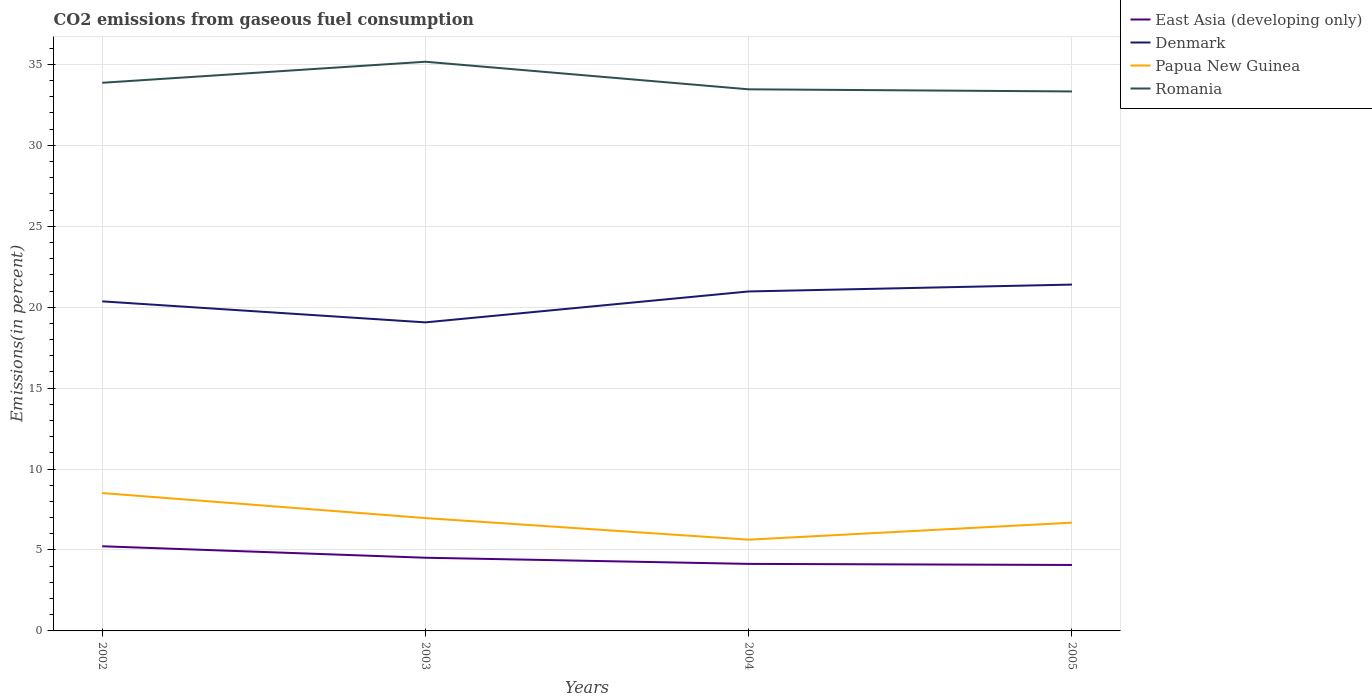Is the number of lines equal to the number of legend labels?
Provide a short and direct response. Yes. Across all years, what is the maximum total CO2 emitted in Denmark?
Offer a terse response. 19.06. In which year was the total CO2 emitted in East Asia (developing only) maximum?
Offer a very short reply. 2005. What is the total total CO2 emitted in Denmark in the graph?
Keep it short and to the point. -1.04. What is the difference between the highest and the second highest total CO2 emitted in Papua New Guinea?
Your answer should be very brief. 2.88. What is the difference between the highest and the lowest total CO2 emitted in East Asia (developing only)?
Provide a succinct answer. 2. How many lines are there?
Your response must be concise. 4. How many years are there in the graph?
Ensure brevity in your answer.  4. What is the difference between two consecutive major ticks on the Y-axis?
Your answer should be compact. 5. Where does the legend appear in the graph?
Offer a terse response. Top right. How are the legend labels stacked?
Your response must be concise. Vertical. What is the title of the graph?
Make the answer very short. CO2 emissions from gaseous fuel consumption. What is the label or title of the Y-axis?
Your answer should be very brief. Emissions(in percent). What is the Emissions(in percent) of East Asia (developing only) in 2002?
Keep it short and to the point. 5.23. What is the Emissions(in percent) in Denmark in 2002?
Provide a short and direct response. 20.36. What is the Emissions(in percent) of Papua New Guinea in 2002?
Ensure brevity in your answer.  8.52. What is the Emissions(in percent) in Romania in 2002?
Your answer should be very brief. 33.86. What is the Emissions(in percent) in East Asia (developing only) in 2003?
Offer a terse response. 4.52. What is the Emissions(in percent) of Denmark in 2003?
Your answer should be compact. 19.06. What is the Emissions(in percent) in Papua New Guinea in 2003?
Provide a succinct answer. 6.97. What is the Emissions(in percent) of Romania in 2003?
Offer a very short reply. 35.16. What is the Emissions(in percent) of East Asia (developing only) in 2004?
Provide a short and direct response. 4.14. What is the Emissions(in percent) of Denmark in 2004?
Ensure brevity in your answer.  20.97. What is the Emissions(in percent) of Papua New Guinea in 2004?
Your response must be concise. 5.64. What is the Emissions(in percent) of Romania in 2004?
Your answer should be compact. 33.46. What is the Emissions(in percent) in East Asia (developing only) in 2005?
Provide a succinct answer. 4.07. What is the Emissions(in percent) in Denmark in 2005?
Ensure brevity in your answer.  21.4. What is the Emissions(in percent) in Papua New Guinea in 2005?
Provide a short and direct response. 6.69. What is the Emissions(in percent) of Romania in 2005?
Give a very brief answer. 33.33. Across all years, what is the maximum Emissions(in percent) of East Asia (developing only)?
Provide a succinct answer. 5.23. Across all years, what is the maximum Emissions(in percent) in Denmark?
Provide a short and direct response. 21.4. Across all years, what is the maximum Emissions(in percent) of Papua New Guinea?
Your answer should be compact. 8.52. Across all years, what is the maximum Emissions(in percent) of Romania?
Provide a short and direct response. 35.16. Across all years, what is the minimum Emissions(in percent) in East Asia (developing only)?
Keep it short and to the point. 4.07. Across all years, what is the minimum Emissions(in percent) of Denmark?
Offer a very short reply. 19.06. Across all years, what is the minimum Emissions(in percent) of Papua New Guinea?
Your response must be concise. 5.64. Across all years, what is the minimum Emissions(in percent) in Romania?
Give a very brief answer. 33.33. What is the total Emissions(in percent) of East Asia (developing only) in the graph?
Make the answer very short. 17.97. What is the total Emissions(in percent) in Denmark in the graph?
Offer a terse response. 81.79. What is the total Emissions(in percent) in Papua New Guinea in the graph?
Provide a short and direct response. 27.81. What is the total Emissions(in percent) of Romania in the graph?
Keep it short and to the point. 135.82. What is the difference between the Emissions(in percent) in East Asia (developing only) in 2002 and that in 2003?
Provide a succinct answer. 0.71. What is the difference between the Emissions(in percent) of Denmark in 2002 and that in 2003?
Give a very brief answer. 1.3. What is the difference between the Emissions(in percent) in Papua New Guinea in 2002 and that in 2003?
Your answer should be compact. 1.55. What is the difference between the Emissions(in percent) of Romania in 2002 and that in 2003?
Give a very brief answer. -1.3. What is the difference between the Emissions(in percent) in East Asia (developing only) in 2002 and that in 2004?
Keep it short and to the point. 1.09. What is the difference between the Emissions(in percent) in Denmark in 2002 and that in 2004?
Ensure brevity in your answer.  -0.61. What is the difference between the Emissions(in percent) of Papua New Guinea in 2002 and that in 2004?
Offer a very short reply. 2.88. What is the difference between the Emissions(in percent) in Romania in 2002 and that in 2004?
Make the answer very short. 0.4. What is the difference between the Emissions(in percent) in East Asia (developing only) in 2002 and that in 2005?
Offer a very short reply. 1.16. What is the difference between the Emissions(in percent) in Denmark in 2002 and that in 2005?
Offer a very short reply. -1.04. What is the difference between the Emissions(in percent) in Papua New Guinea in 2002 and that in 2005?
Your response must be concise. 1.83. What is the difference between the Emissions(in percent) of Romania in 2002 and that in 2005?
Offer a terse response. 0.53. What is the difference between the Emissions(in percent) in East Asia (developing only) in 2003 and that in 2004?
Provide a succinct answer. 0.38. What is the difference between the Emissions(in percent) of Denmark in 2003 and that in 2004?
Provide a short and direct response. -1.91. What is the difference between the Emissions(in percent) in Papua New Guinea in 2003 and that in 2004?
Your response must be concise. 1.33. What is the difference between the Emissions(in percent) in Romania in 2003 and that in 2004?
Give a very brief answer. 1.7. What is the difference between the Emissions(in percent) of East Asia (developing only) in 2003 and that in 2005?
Your response must be concise. 0.45. What is the difference between the Emissions(in percent) of Denmark in 2003 and that in 2005?
Your response must be concise. -2.33. What is the difference between the Emissions(in percent) of Papua New Guinea in 2003 and that in 2005?
Make the answer very short. 0.28. What is the difference between the Emissions(in percent) in Romania in 2003 and that in 2005?
Provide a short and direct response. 1.83. What is the difference between the Emissions(in percent) of East Asia (developing only) in 2004 and that in 2005?
Offer a very short reply. 0.07. What is the difference between the Emissions(in percent) of Denmark in 2004 and that in 2005?
Offer a very short reply. -0.42. What is the difference between the Emissions(in percent) in Papua New Guinea in 2004 and that in 2005?
Your answer should be compact. -1.05. What is the difference between the Emissions(in percent) in Romania in 2004 and that in 2005?
Make the answer very short. 0.13. What is the difference between the Emissions(in percent) in East Asia (developing only) in 2002 and the Emissions(in percent) in Denmark in 2003?
Give a very brief answer. -13.83. What is the difference between the Emissions(in percent) in East Asia (developing only) in 2002 and the Emissions(in percent) in Papua New Guinea in 2003?
Provide a short and direct response. -1.74. What is the difference between the Emissions(in percent) in East Asia (developing only) in 2002 and the Emissions(in percent) in Romania in 2003?
Offer a very short reply. -29.93. What is the difference between the Emissions(in percent) of Denmark in 2002 and the Emissions(in percent) of Papua New Guinea in 2003?
Offer a terse response. 13.39. What is the difference between the Emissions(in percent) in Denmark in 2002 and the Emissions(in percent) in Romania in 2003?
Ensure brevity in your answer.  -14.8. What is the difference between the Emissions(in percent) in Papua New Guinea in 2002 and the Emissions(in percent) in Romania in 2003?
Make the answer very short. -26.65. What is the difference between the Emissions(in percent) of East Asia (developing only) in 2002 and the Emissions(in percent) of Denmark in 2004?
Keep it short and to the point. -15.74. What is the difference between the Emissions(in percent) in East Asia (developing only) in 2002 and the Emissions(in percent) in Papua New Guinea in 2004?
Offer a very short reply. -0.41. What is the difference between the Emissions(in percent) of East Asia (developing only) in 2002 and the Emissions(in percent) of Romania in 2004?
Make the answer very short. -28.23. What is the difference between the Emissions(in percent) in Denmark in 2002 and the Emissions(in percent) in Papua New Guinea in 2004?
Give a very brief answer. 14.72. What is the difference between the Emissions(in percent) in Denmark in 2002 and the Emissions(in percent) in Romania in 2004?
Your response must be concise. -13.1. What is the difference between the Emissions(in percent) in Papua New Guinea in 2002 and the Emissions(in percent) in Romania in 2004?
Make the answer very short. -24.94. What is the difference between the Emissions(in percent) in East Asia (developing only) in 2002 and the Emissions(in percent) in Denmark in 2005?
Your answer should be compact. -16.17. What is the difference between the Emissions(in percent) in East Asia (developing only) in 2002 and the Emissions(in percent) in Papua New Guinea in 2005?
Your answer should be compact. -1.46. What is the difference between the Emissions(in percent) in East Asia (developing only) in 2002 and the Emissions(in percent) in Romania in 2005?
Offer a terse response. -28.1. What is the difference between the Emissions(in percent) in Denmark in 2002 and the Emissions(in percent) in Papua New Guinea in 2005?
Keep it short and to the point. 13.67. What is the difference between the Emissions(in percent) in Denmark in 2002 and the Emissions(in percent) in Romania in 2005?
Provide a succinct answer. -12.97. What is the difference between the Emissions(in percent) in Papua New Guinea in 2002 and the Emissions(in percent) in Romania in 2005?
Ensure brevity in your answer.  -24.81. What is the difference between the Emissions(in percent) of East Asia (developing only) in 2003 and the Emissions(in percent) of Denmark in 2004?
Make the answer very short. -16.45. What is the difference between the Emissions(in percent) in East Asia (developing only) in 2003 and the Emissions(in percent) in Papua New Guinea in 2004?
Your response must be concise. -1.12. What is the difference between the Emissions(in percent) of East Asia (developing only) in 2003 and the Emissions(in percent) of Romania in 2004?
Your answer should be compact. -28.94. What is the difference between the Emissions(in percent) in Denmark in 2003 and the Emissions(in percent) in Papua New Guinea in 2004?
Make the answer very short. 13.43. What is the difference between the Emissions(in percent) of Denmark in 2003 and the Emissions(in percent) of Romania in 2004?
Your answer should be compact. -14.4. What is the difference between the Emissions(in percent) of Papua New Guinea in 2003 and the Emissions(in percent) of Romania in 2004?
Make the answer very short. -26.49. What is the difference between the Emissions(in percent) of East Asia (developing only) in 2003 and the Emissions(in percent) of Denmark in 2005?
Offer a very short reply. -16.88. What is the difference between the Emissions(in percent) in East Asia (developing only) in 2003 and the Emissions(in percent) in Papua New Guinea in 2005?
Your answer should be very brief. -2.17. What is the difference between the Emissions(in percent) in East Asia (developing only) in 2003 and the Emissions(in percent) in Romania in 2005?
Ensure brevity in your answer.  -28.81. What is the difference between the Emissions(in percent) of Denmark in 2003 and the Emissions(in percent) of Papua New Guinea in 2005?
Ensure brevity in your answer.  12.37. What is the difference between the Emissions(in percent) in Denmark in 2003 and the Emissions(in percent) in Romania in 2005?
Your answer should be very brief. -14.27. What is the difference between the Emissions(in percent) in Papua New Guinea in 2003 and the Emissions(in percent) in Romania in 2005?
Your answer should be very brief. -26.36. What is the difference between the Emissions(in percent) in East Asia (developing only) in 2004 and the Emissions(in percent) in Denmark in 2005?
Make the answer very short. -17.26. What is the difference between the Emissions(in percent) in East Asia (developing only) in 2004 and the Emissions(in percent) in Papua New Guinea in 2005?
Give a very brief answer. -2.55. What is the difference between the Emissions(in percent) in East Asia (developing only) in 2004 and the Emissions(in percent) in Romania in 2005?
Your answer should be very brief. -29.19. What is the difference between the Emissions(in percent) of Denmark in 2004 and the Emissions(in percent) of Papua New Guinea in 2005?
Offer a terse response. 14.28. What is the difference between the Emissions(in percent) of Denmark in 2004 and the Emissions(in percent) of Romania in 2005?
Give a very brief answer. -12.36. What is the difference between the Emissions(in percent) of Papua New Guinea in 2004 and the Emissions(in percent) of Romania in 2005?
Provide a succinct answer. -27.69. What is the average Emissions(in percent) of East Asia (developing only) per year?
Your answer should be very brief. 4.49. What is the average Emissions(in percent) in Denmark per year?
Provide a succinct answer. 20.45. What is the average Emissions(in percent) of Papua New Guinea per year?
Offer a very short reply. 6.95. What is the average Emissions(in percent) of Romania per year?
Offer a very short reply. 33.95. In the year 2002, what is the difference between the Emissions(in percent) of East Asia (developing only) and Emissions(in percent) of Denmark?
Your answer should be very brief. -15.13. In the year 2002, what is the difference between the Emissions(in percent) in East Asia (developing only) and Emissions(in percent) in Papua New Guinea?
Make the answer very short. -3.29. In the year 2002, what is the difference between the Emissions(in percent) of East Asia (developing only) and Emissions(in percent) of Romania?
Provide a short and direct response. -28.63. In the year 2002, what is the difference between the Emissions(in percent) in Denmark and Emissions(in percent) in Papua New Guinea?
Your response must be concise. 11.84. In the year 2002, what is the difference between the Emissions(in percent) in Denmark and Emissions(in percent) in Romania?
Provide a short and direct response. -13.5. In the year 2002, what is the difference between the Emissions(in percent) of Papua New Guinea and Emissions(in percent) of Romania?
Offer a terse response. -25.35. In the year 2003, what is the difference between the Emissions(in percent) of East Asia (developing only) and Emissions(in percent) of Denmark?
Offer a terse response. -14.54. In the year 2003, what is the difference between the Emissions(in percent) in East Asia (developing only) and Emissions(in percent) in Papua New Guinea?
Make the answer very short. -2.45. In the year 2003, what is the difference between the Emissions(in percent) of East Asia (developing only) and Emissions(in percent) of Romania?
Provide a succinct answer. -30.64. In the year 2003, what is the difference between the Emissions(in percent) in Denmark and Emissions(in percent) in Papua New Guinea?
Provide a short and direct response. 12.09. In the year 2003, what is the difference between the Emissions(in percent) of Denmark and Emissions(in percent) of Romania?
Offer a very short reply. -16.1. In the year 2003, what is the difference between the Emissions(in percent) in Papua New Guinea and Emissions(in percent) in Romania?
Give a very brief answer. -28.19. In the year 2004, what is the difference between the Emissions(in percent) of East Asia (developing only) and Emissions(in percent) of Denmark?
Offer a terse response. -16.83. In the year 2004, what is the difference between the Emissions(in percent) in East Asia (developing only) and Emissions(in percent) in Papua New Guinea?
Offer a terse response. -1.5. In the year 2004, what is the difference between the Emissions(in percent) of East Asia (developing only) and Emissions(in percent) of Romania?
Provide a short and direct response. -29.32. In the year 2004, what is the difference between the Emissions(in percent) of Denmark and Emissions(in percent) of Papua New Guinea?
Offer a terse response. 15.34. In the year 2004, what is the difference between the Emissions(in percent) in Denmark and Emissions(in percent) in Romania?
Give a very brief answer. -12.49. In the year 2004, what is the difference between the Emissions(in percent) in Papua New Guinea and Emissions(in percent) in Romania?
Make the answer very short. -27.82. In the year 2005, what is the difference between the Emissions(in percent) in East Asia (developing only) and Emissions(in percent) in Denmark?
Your answer should be very brief. -17.32. In the year 2005, what is the difference between the Emissions(in percent) in East Asia (developing only) and Emissions(in percent) in Papua New Guinea?
Offer a very short reply. -2.61. In the year 2005, what is the difference between the Emissions(in percent) in East Asia (developing only) and Emissions(in percent) in Romania?
Keep it short and to the point. -29.26. In the year 2005, what is the difference between the Emissions(in percent) of Denmark and Emissions(in percent) of Papua New Guinea?
Ensure brevity in your answer.  14.71. In the year 2005, what is the difference between the Emissions(in percent) of Denmark and Emissions(in percent) of Romania?
Provide a short and direct response. -11.93. In the year 2005, what is the difference between the Emissions(in percent) of Papua New Guinea and Emissions(in percent) of Romania?
Ensure brevity in your answer.  -26.64. What is the ratio of the Emissions(in percent) in East Asia (developing only) in 2002 to that in 2003?
Keep it short and to the point. 1.16. What is the ratio of the Emissions(in percent) of Denmark in 2002 to that in 2003?
Your response must be concise. 1.07. What is the ratio of the Emissions(in percent) in Papua New Guinea in 2002 to that in 2003?
Your answer should be very brief. 1.22. What is the ratio of the Emissions(in percent) of Romania in 2002 to that in 2003?
Provide a short and direct response. 0.96. What is the ratio of the Emissions(in percent) in East Asia (developing only) in 2002 to that in 2004?
Offer a terse response. 1.26. What is the ratio of the Emissions(in percent) in Denmark in 2002 to that in 2004?
Ensure brevity in your answer.  0.97. What is the ratio of the Emissions(in percent) in Papua New Guinea in 2002 to that in 2004?
Offer a terse response. 1.51. What is the ratio of the Emissions(in percent) in Romania in 2002 to that in 2004?
Your response must be concise. 1.01. What is the ratio of the Emissions(in percent) in East Asia (developing only) in 2002 to that in 2005?
Your answer should be very brief. 1.28. What is the ratio of the Emissions(in percent) of Denmark in 2002 to that in 2005?
Keep it short and to the point. 0.95. What is the ratio of the Emissions(in percent) of Papua New Guinea in 2002 to that in 2005?
Your answer should be very brief. 1.27. What is the ratio of the Emissions(in percent) in Romania in 2002 to that in 2005?
Ensure brevity in your answer.  1.02. What is the ratio of the Emissions(in percent) in East Asia (developing only) in 2003 to that in 2004?
Make the answer very short. 1.09. What is the ratio of the Emissions(in percent) in Denmark in 2003 to that in 2004?
Keep it short and to the point. 0.91. What is the ratio of the Emissions(in percent) of Papua New Guinea in 2003 to that in 2004?
Give a very brief answer. 1.24. What is the ratio of the Emissions(in percent) in Romania in 2003 to that in 2004?
Your answer should be compact. 1.05. What is the ratio of the Emissions(in percent) of East Asia (developing only) in 2003 to that in 2005?
Your answer should be very brief. 1.11. What is the ratio of the Emissions(in percent) in Denmark in 2003 to that in 2005?
Give a very brief answer. 0.89. What is the ratio of the Emissions(in percent) in Papua New Guinea in 2003 to that in 2005?
Offer a very short reply. 1.04. What is the ratio of the Emissions(in percent) of Romania in 2003 to that in 2005?
Offer a terse response. 1.05. What is the ratio of the Emissions(in percent) in East Asia (developing only) in 2004 to that in 2005?
Give a very brief answer. 1.02. What is the ratio of the Emissions(in percent) in Denmark in 2004 to that in 2005?
Offer a very short reply. 0.98. What is the ratio of the Emissions(in percent) in Papua New Guinea in 2004 to that in 2005?
Ensure brevity in your answer.  0.84. What is the ratio of the Emissions(in percent) of Romania in 2004 to that in 2005?
Provide a short and direct response. 1. What is the difference between the highest and the second highest Emissions(in percent) in East Asia (developing only)?
Provide a succinct answer. 0.71. What is the difference between the highest and the second highest Emissions(in percent) of Denmark?
Provide a succinct answer. 0.42. What is the difference between the highest and the second highest Emissions(in percent) in Papua New Guinea?
Your answer should be compact. 1.55. What is the difference between the highest and the second highest Emissions(in percent) of Romania?
Your response must be concise. 1.3. What is the difference between the highest and the lowest Emissions(in percent) of East Asia (developing only)?
Provide a short and direct response. 1.16. What is the difference between the highest and the lowest Emissions(in percent) in Denmark?
Offer a terse response. 2.33. What is the difference between the highest and the lowest Emissions(in percent) in Papua New Guinea?
Make the answer very short. 2.88. What is the difference between the highest and the lowest Emissions(in percent) of Romania?
Provide a succinct answer. 1.83. 